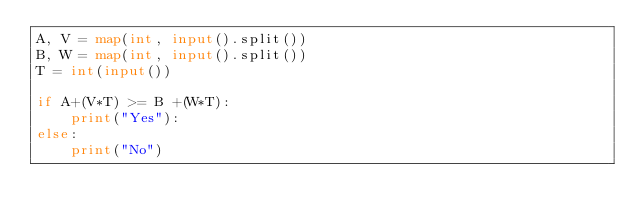Convert code to text. <code><loc_0><loc_0><loc_500><loc_500><_Python_>A, V = map(int, input().split())
B, W = map(int, input().split())
T = int(input())

if A+(V*T) >= B +(W*T):
    print("Yes"):
else:
    print("No")</code> 